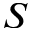<formula> <loc_0><loc_0><loc_500><loc_500>S</formula> 